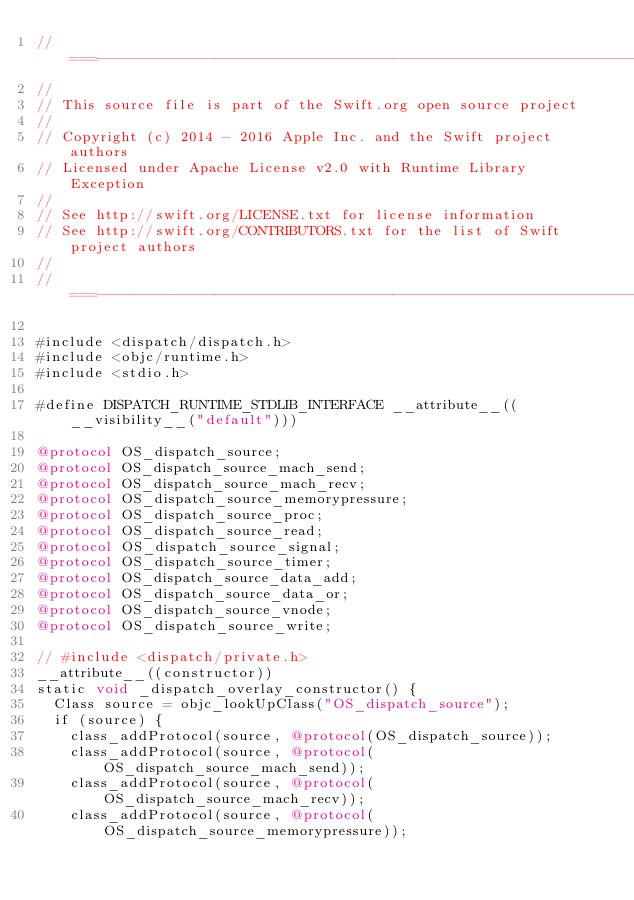<code> <loc_0><loc_0><loc_500><loc_500><_ObjectiveC_>//===----------------------------------------------------------------------===//
//
// This source file is part of the Swift.org open source project
//
// Copyright (c) 2014 - 2016 Apple Inc. and the Swift project authors
// Licensed under Apache License v2.0 with Runtime Library Exception
//
// See http://swift.org/LICENSE.txt for license information
// See http://swift.org/CONTRIBUTORS.txt for the list of Swift project authors
//
//===----------------------------------------------------------------------===//

#include <dispatch/dispatch.h>
#include <objc/runtime.h>
#include <stdio.h>

#define DISPATCH_RUNTIME_STDLIB_INTERFACE __attribute__((__visibility__("default")))

@protocol OS_dispatch_source;
@protocol OS_dispatch_source_mach_send;
@protocol OS_dispatch_source_mach_recv;
@protocol OS_dispatch_source_memorypressure;
@protocol OS_dispatch_source_proc;
@protocol OS_dispatch_source_read;
@protocol OS_dispatch_source_signal;
@protocol OS_dispatch_source_timer;
@protocol OS_dispatch_source_data_add;
@protocol OS_dispatch_source_data_or;
@protocol OS_dispatch_source_vnode;
@protocol OS_dispatch_source_write;

// #include <dispatch/private.h>
__attribute__((constructor))
static void _dispatch_overlay_constructor() {
  Class source = objc_lookUpClass("OS_dispatch_source");
  if (source) {
    class_addProtocol(source, @protocol(OS_dispatch_source));
    class_addProtocol(source, @protocol(OS_dispatch_source_mach_send));
    class_addProtocol(source, @protocol(OS_dispatch_source_mach_recv));
    class_addProtocol(source, @protocol(OS_dispatch_source_memorypressure));</code> 